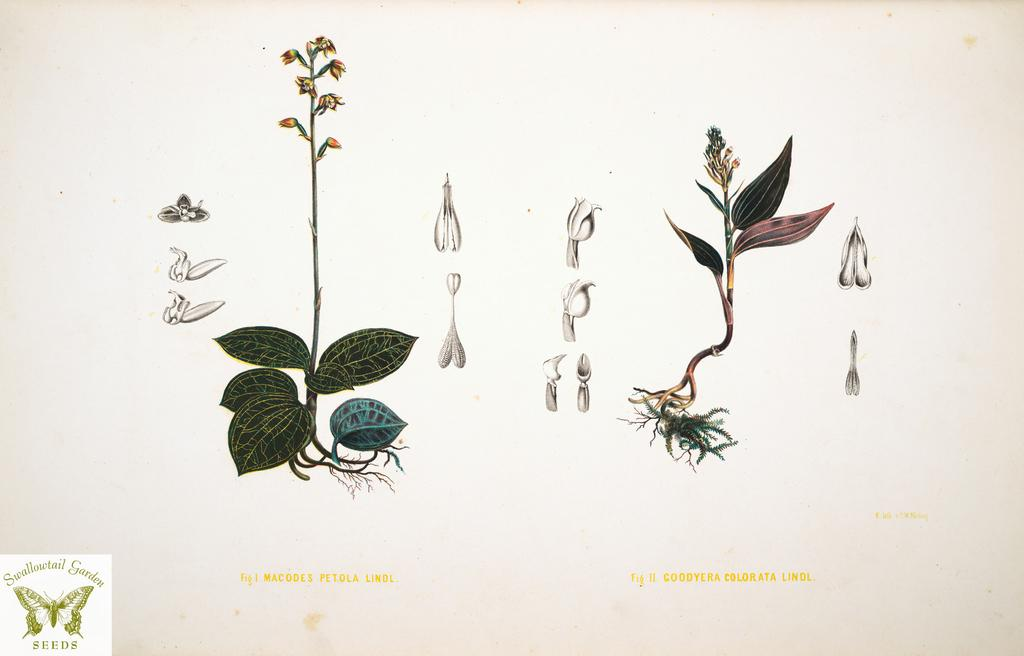What is depicted in the drawing in the image? The drawing contains a depiction of plant parts. What is the color of the paper on which the drawing is made? The drawing is on a white paper. Can you describe any additional features on the paper? There is a butterfly watermark on the left bottom side of the paper. What type of activity is the butterfly engaged in on the right side of the paper? There is no butterfly visible on the right side of the paper in the image. 